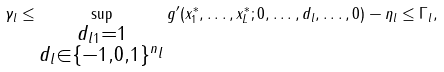Convert formula to latex. <formula><loc_0><loc_0><loc_500><loc_500>\gamma _ { l } \leq \sup _ { \substack { \| d _ { l } \| _ { 1 } = 1 \\ d _ { l } \in \{ - 1 , 0 , 1 \} ^ { n _ { l } } } } g ^ { \prime } ( x _ { 1 } ^ { * } , \dots , x _ { L } ^ { * } ; 0 , \dots , d _ { l } , \dots , 0 ) - \eta _ { l } \leq \Gamma _ { l } ,</formula> 